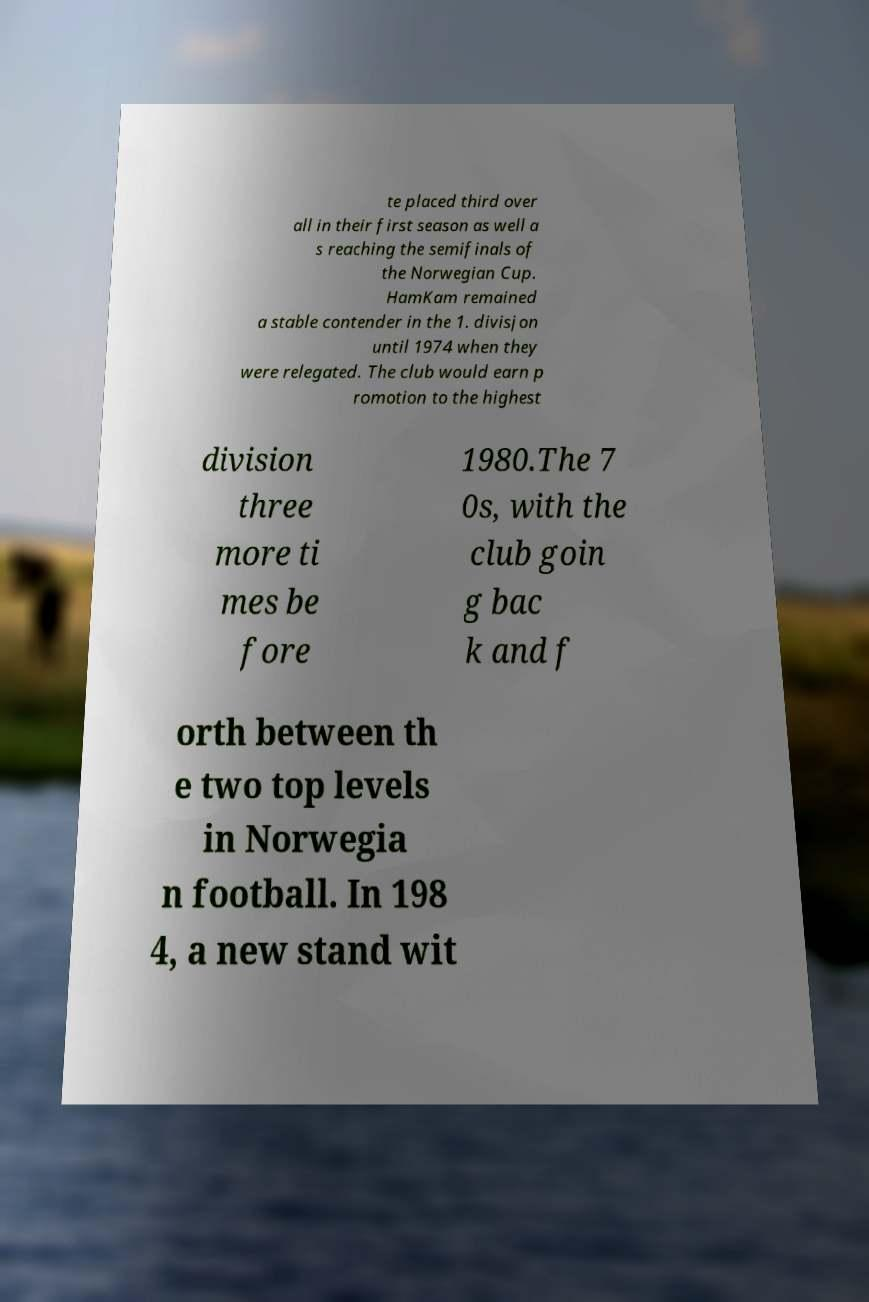Please identify and transcribe the text found in this image. te placed third over all in their first season as well a s reaching the semifinals of the Norwegian Cup. HamKam remained a stable contender in the 1. divisjon until 1974 when they were relegated. The club would earn p romotion to the highest division three more ti mes be fore 1980.The 7 0s, with the club goin g bac k and f orth between th e two top levels in Norwegia n football. In 198 4, a new stand wit 